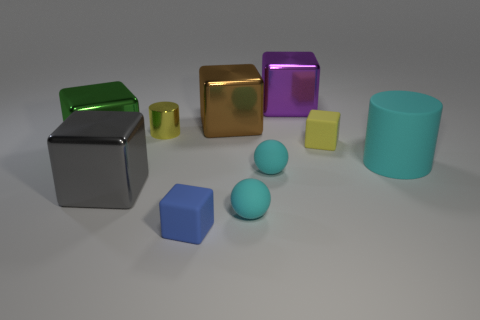Are any tiny cubes visible?
Keep it short and to the point. Yes. What is the color of the big metallic block that is to the left of the gray metal block?
Keep it short and to the point. Green. There is a cube that is the same color as the tiny metallic thing; what material is it?
Give a very brief answer. Rubber. Are there any matte cylinders to the left of the small yellow shiny cylinder?
Offer a very short reply. No. Is the number of red matte blocks greater than the number of large rubber cylinders?
Give a very brief answer. No. The rubber block behind the tiny cube that is left of the metal thing that is behind the brown shiny cube is what color?
Give a very brief answer. Yellow. The cylinder that is made of the same material as the yellow block is what color?
Provide a short and direct response. Cyan. What number of things are either things right of the large purple metallic object or metal objects that are to the left of the small shiny cylinder?
Give a very brief answer. 4. There is a shiny block in front of the large matte cylinder; is its size the same as the cylinder to the right of the tiny metallic thing?
Give a very brief answer. Yes. There is another tiny rubber thing that is the same shape as the small blue matte object; what color is it?
Make the answer very short. Yellow. 